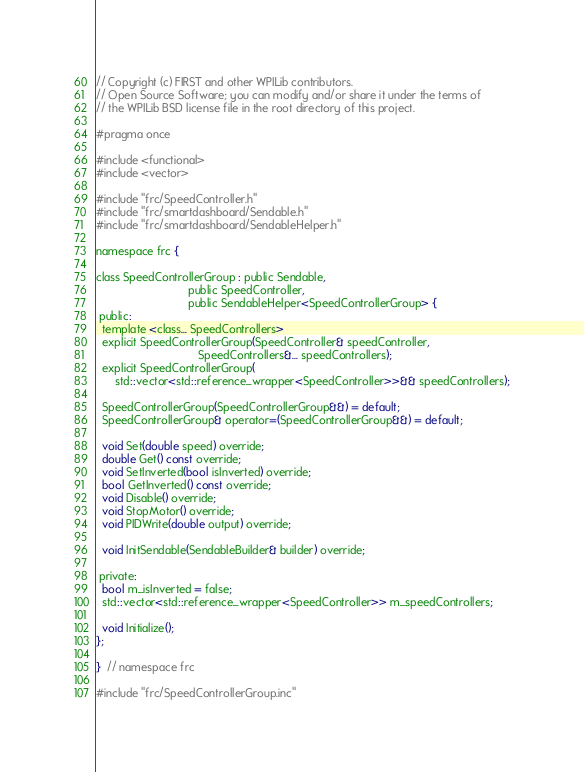Convert code to text. <code><loc_0><loc_0><loc_500><loc_500><_C_>// Copyright (c) FIRST and other WPILib contributors.
// Open Source Software; you can modify and/or share it under the terms of
// the WPILib BSD license file in the root directory of this project.

#pragma once

#include <functional>
#include <vector>

#include "frc/SpeedController.h"
#include "frc/smartdashboard/Sendable.h"
#include "frc/smartdashboard/SendableHelper.h"

namespace frc {

class SpeedControllerGroup : public Sendable,
                             public SpeedController,
                             public SendableHelper<SpeedControllerGroup> {
 public:
  template <class... SpeedControllers>
  explicit SpeedControllerGroup(SpeedController& speedController,
                                SpeedControllers&... speedControllers);
  explicit SpeedControllerGroup(
      std::vector<std::reference_wrapper<SpeedController>>&& speedControllers);

  SpeedControllerGroup(SpeedControllerGroup&&) = default;
  SpeedControllerGroup& operator=(SpeedControllerGroup&&) = default;

  void Set(double speed) override;
  double Get() const override;
  void SetInverted(bool isInverted) override;
  bool GetInverted() const override;
  void Disable() override;
  void StopMotor() override;
  void PIDWrite(double output) override;

  void InitSendable(SendableBuilder& builder) override;

 private:
  bool m_isInverted = false;
  std::vector<std::reference_wrapper<SpeedController>> m_speedControllers;

  void Initialize();
};

}  // namespace frc

#include "frc/SpeedControllerGroup.inc"
</code> 